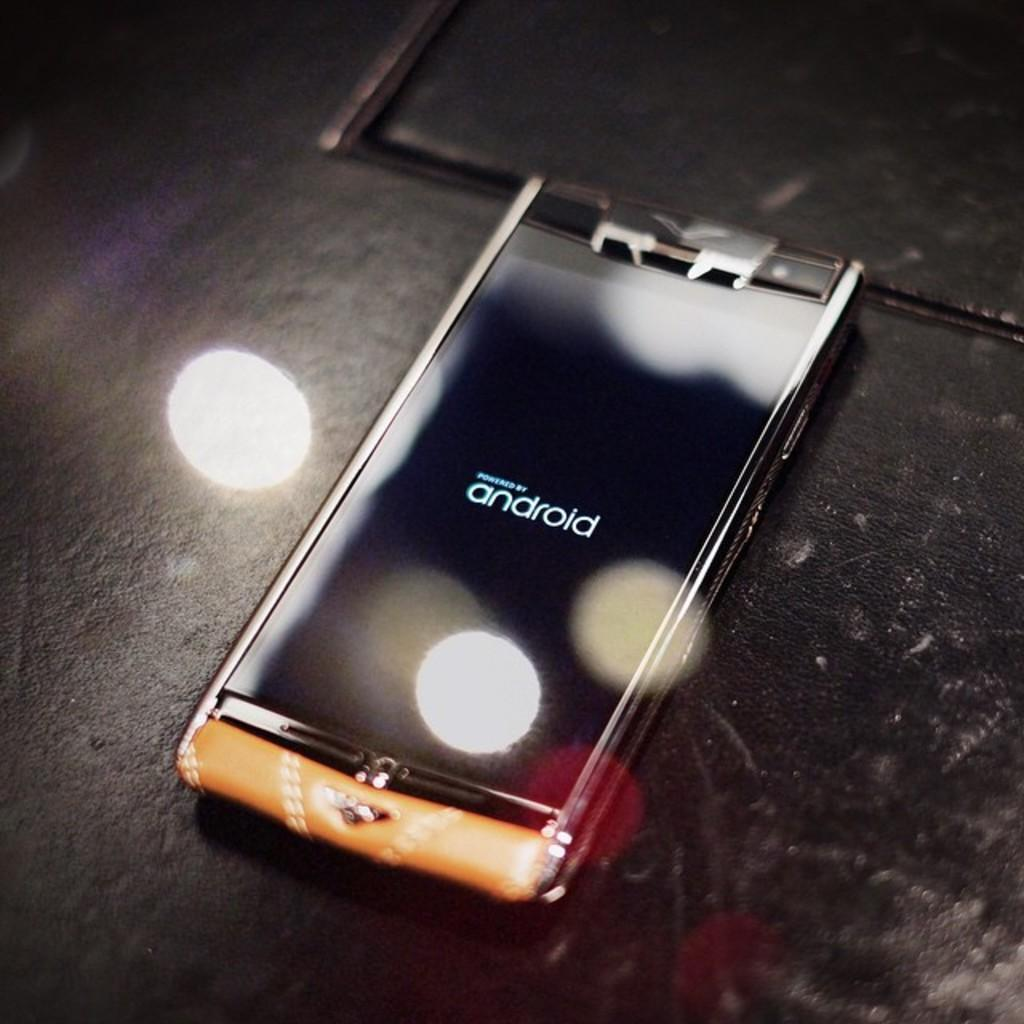<image>
Write a terse but informative summary of the picture. Cellphone sitting on a table with a screen that says powered by Android. 